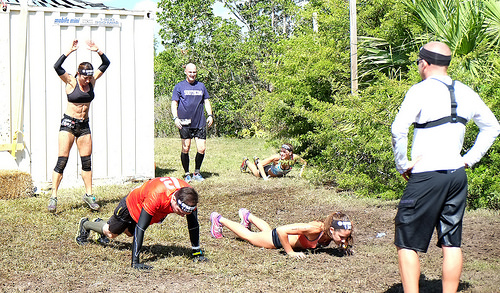<image>
Can you confirm if the girl is next to the boy? Yes. The girl is positioned adjacent to the boy, located nearby in the same general area. 